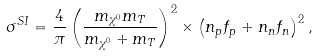Convert formula to latex. <formula><loc_0><loc_0><loc_500><loc_500>\sigma ^ { S I } = \frac { 4 } { \pi } \left ( \frac { m _ { \chi ^ { 0 } } m _ { T } } { m _ { \chi ^ { 0 } } + m _ { T } } \right ) ^ { 2 } \times \left ( n _ { p } f _ { p } + n _ { n } f _ { n } \right ) ^ { 2 } ,</formula> 